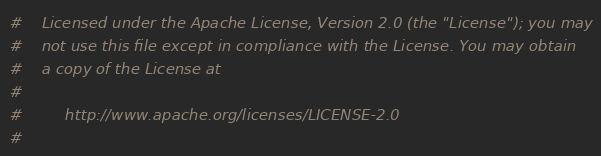<code> <loc_0><loc_0><loc_500><loc_500><_Python_>#    Licensed under the Apache License, Version 2.0 (the "License"); you may
#    not use this file except in compliance with the License. You may obtain
#    a copy of the License at
#
#         http://www.apache.org/licenses/LICENSE-2.0
#</code> 